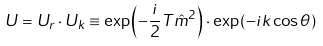<formula> <loc_0><loc_0><loc_500><loc_500>U = U _ { r } \cdot U _ { k } \equiv \exp \left ( - \frac { i } { 2 } T { \hat { m } } ^ { 2 } \right ) \cdot \exp \left ( - i k \cos \theta \right )</formula> 